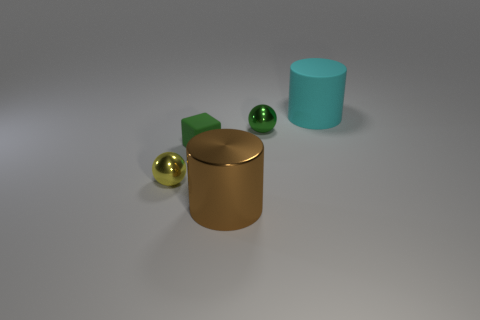What number of things are big shiny things that are on the left side of the big cyan matte cylinder or shiny things in front of the small block?
Offer a very short reply. 2. Are there any other things that are the same color as the large rubber cylinder?
Provide a succinct answer. No. There is a large cylinder in front of the tiny shiny thing that is left of the rubber object on the left side of the large brown shiny object; what is its color?
Give a very brief answer. Brown. There is a cylinder that is to the left of the metal thing that is behind the cube; what size is it?
Keep it short and to the point. Large. What is the object that is both on the right side of the yellow metal thing and left of the brown shiny cylinder made of?
Make the answer very short. Rubber. Does the green cube have the same size as the cyan matte cylinder behind the cube?
Give a very brief answer. No. Are there any large blue metal spheres?
Your response must be concise. No. There is a large brown thing that is the same shape as the large cyan thing; what material is it?
Keep it short and to the point. Metal. There is a cylinder to the left of the matte thing that is behind the metallic sphere to the right of the large brown cylinder; how big is it?
Ensure brevity in your answer.  Large. Are there any cyan rubber cylinders behind the green cube?
Your response must be concise. Yes. 